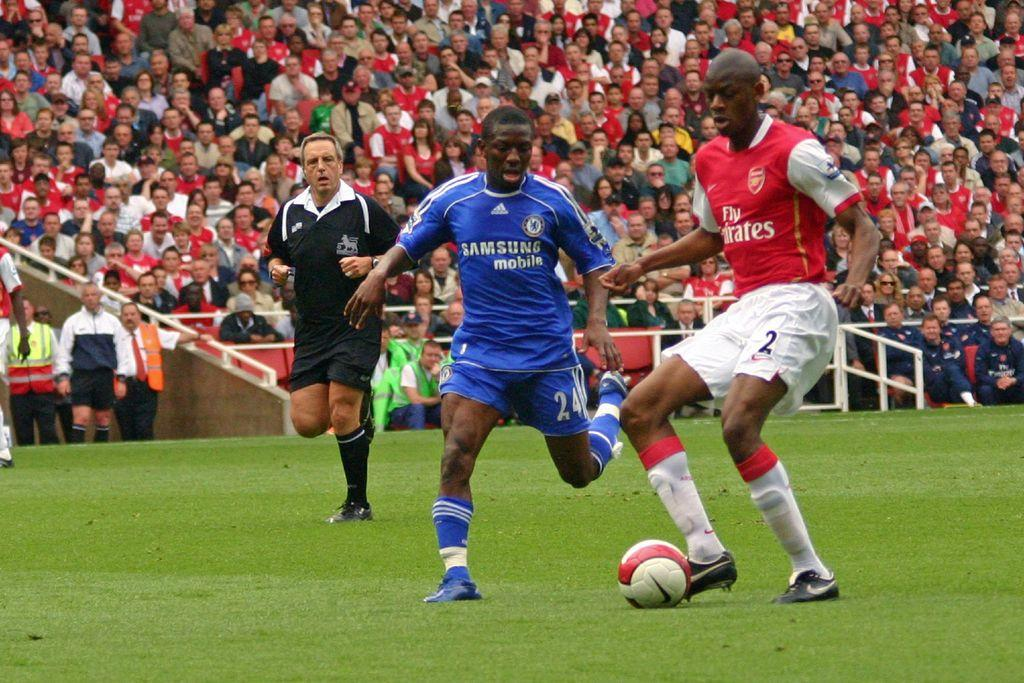What is happening in the image involving a group of people? Some people in the group are playing football, while others are sitting on chairs. What object is on the ground in the image? There is a ball on the ground in the image. Can you describe the activities of the people in the group? Some people are playing football, while others are sitting and not actively participating in the game. Are there any spiders crawling on the chairs in the image? There is no mention of spiders in the image, so we cannot determine if any are present. 